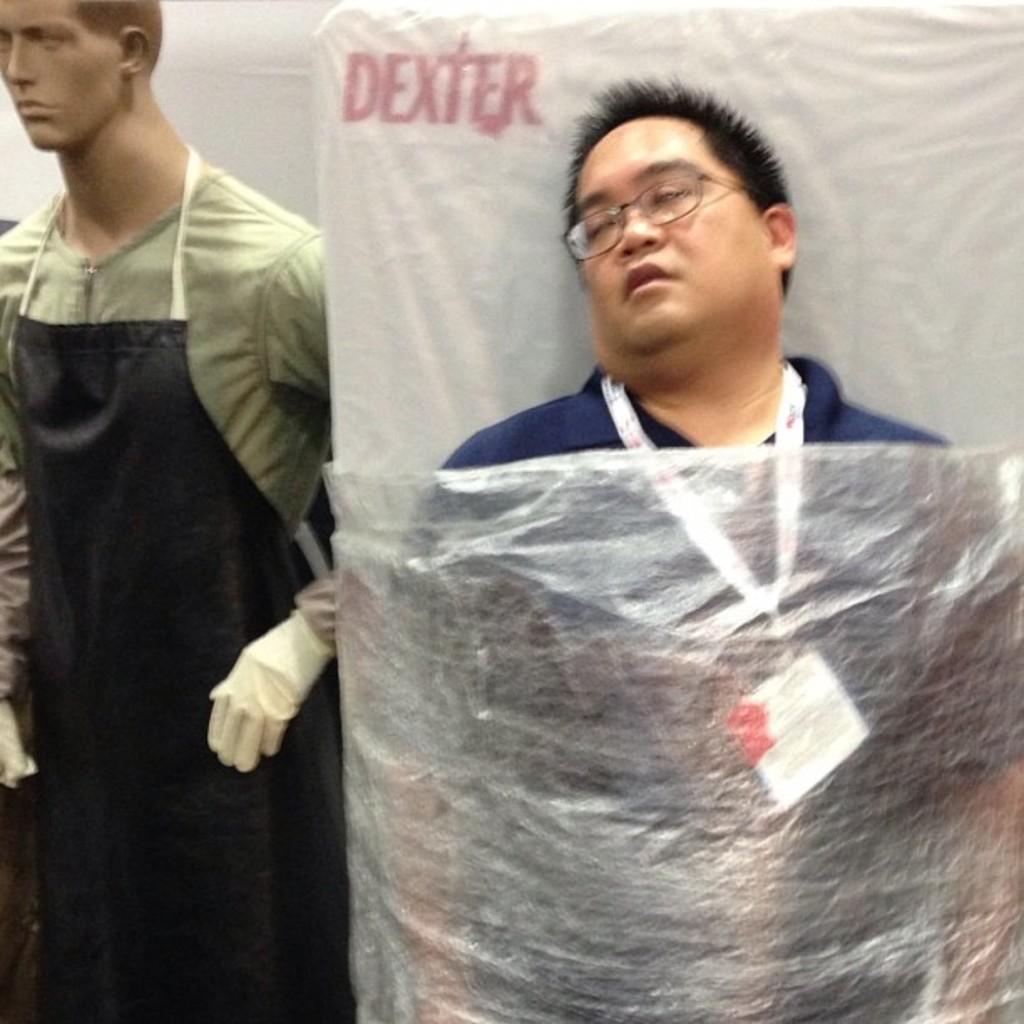Could you give a brief overview of what you see in this image? On the right side of the image we can see a person and the bed. On the left side of the image there is a mannequin. In the background we can see wall. 